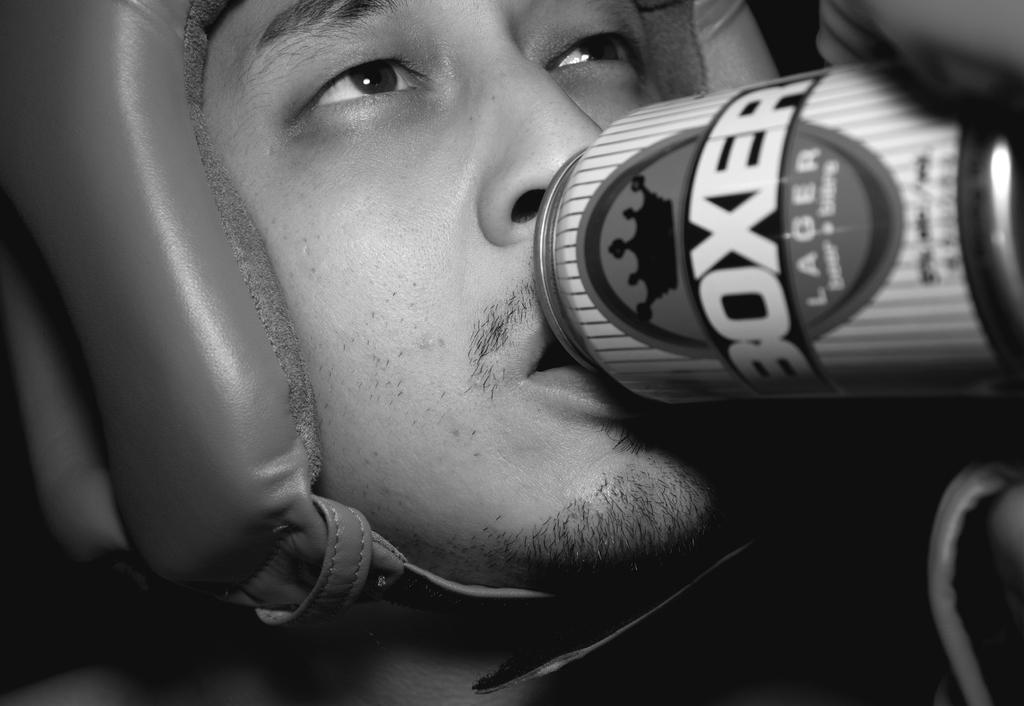<image>
Relay a brief, clear account of the picture shown. A man with headgear on is drinking from a can that says Boxer Lager. 